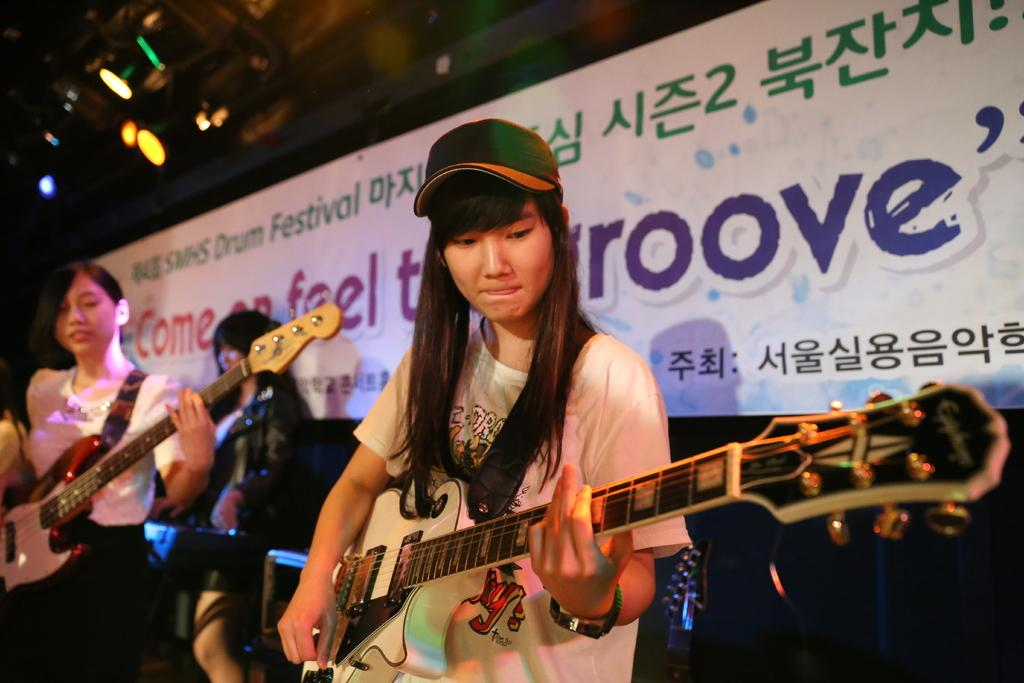What are the two women in the image doing? The two women in the image are playing guitar. Is there anyone else in the image besides the two women playing guitar? Yes, there is another woman standing behind them. What can be seen hanging above the women in the image? There is a banner with text visible in the image. What is present on the roof in the image? Lights are present on the roof in the image. What type of pipe is being used by the women to play the guitar in the image? The women are playing a guitar, which is a stringed musical instrument, and not a pipe. There are no pipes present in the image. 